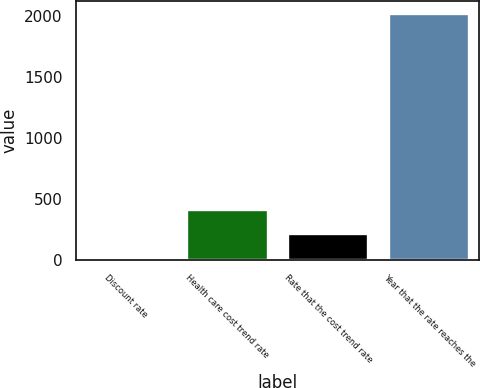Convert chart to OTSL. <chart><loc_0><loc_0><loc_500><loc_500><bar_chart><fcel>Discount rate<fcel>Health care cost trend rate<fcel>Rate that the cost trend rate<fcel>Year that the rate reaches the<nl><fcel>4.2<fcel>407.76<fcel>205.98<fcel>2022<nl></chart> 